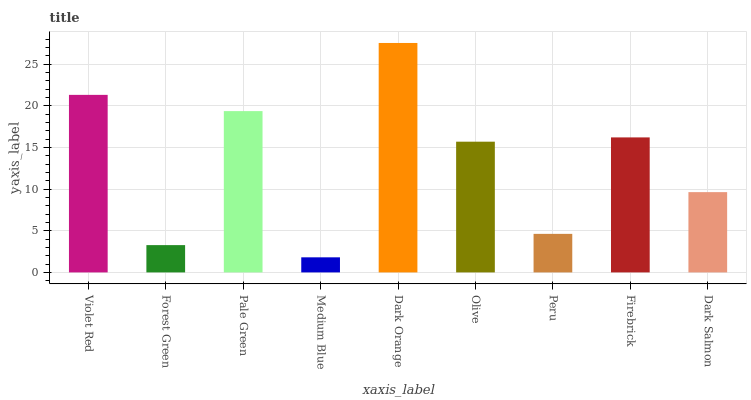Is Medium Blue the minimum?
Answer yes or no. Yes. Is Dark Orange the maximum?
Answer yes or no. Yes. Is Forest Green the minimum?
Answer yes or no. No. Is Forest Green the maximum?
Answer yes or no. No. Is Violet Red greater than Forest Green?
Answer yes or no. Yes. Is Forest Green less than Violet Red?
Answer yes or no. Yes. Is Forest Green greater than Violet Red?
Answer yes or no. No. Is Violet Red less than Forest Green?
Answer yes or no. No. Is Olive the high median?
Answer yes or no. Yes. Is Olive the low median?
Answer yes or no. Yes. Is Dark Orange the high median?
Answer yes or no. No. Is Violet Red the low median?
Answer yes or no. No. 